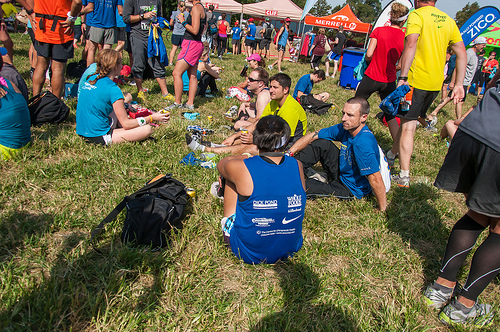<image>
Is there a pink shorts on the guy? No. The pink shorts is not positioned on the guy. They may be near each other, but the pink shorts is not supported by or resting on top of the guy. 